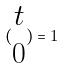Convert formula to latex. <formula><loc_0><loc_0><loc_500><loc_500>( \begin{matrix} t \\ 0 \end{matrix} ) = 1</formula> 